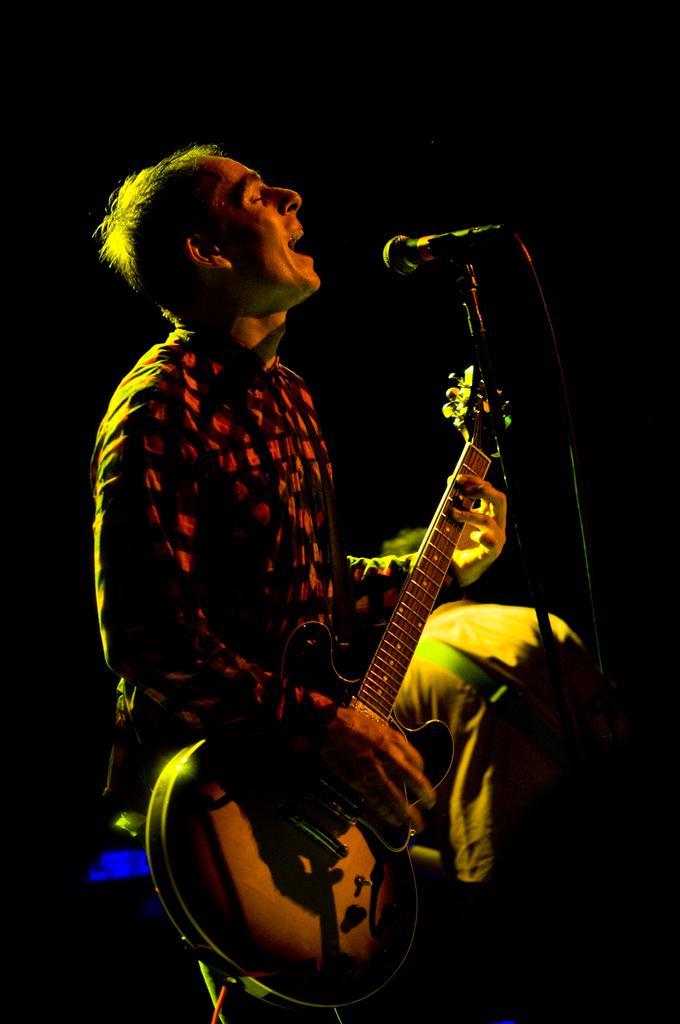Could you give a brief overview of what you see in this image? In this image In the middle there is a man he is playing guitar and he is singing. On the right there is a mic. In the background there is a person. 